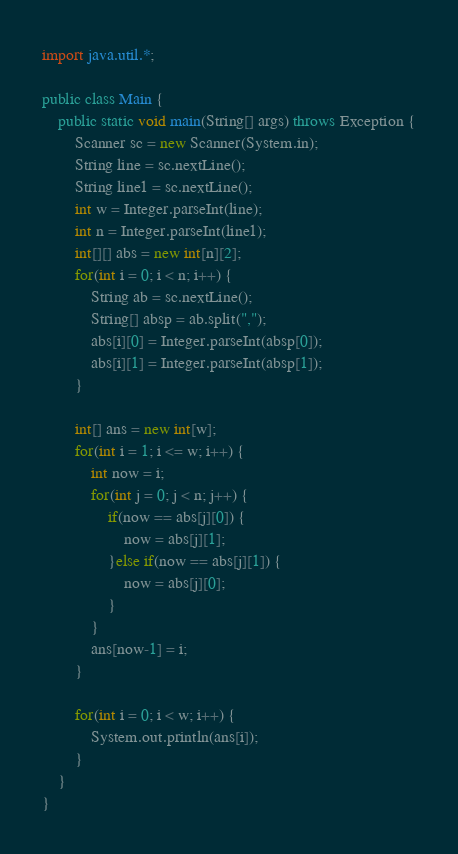Convert code to text. <code><loc_0><loc_0><loc_500><loc_500><_Java_>import java.util.*;

public class Main {
    public static void main(String[] args) throws Exception {
        Scanner sc = new Scanner(System.in);
        String line = sc.nextLine();
        String line1 = sc.nextLine();
        int w = Integer.parseInt(line);
        int n = Integer.parseInt(line1);
        int[][] abs = new int[n][2];
        for(int i = 0; i < n; i++) {
            String ab = sc.nextLine();
            String[] absp = ab.split(",");
            abs[i][0] = Integer.parseInt(absp[0]);
            abs[i][1] = Integer.parseInt(absp[1]);
        }
        
        int[] ans = new int[w];
        for(int i = 1; i <= w; i++) {
            int now = i;
            for(int j = 0; j < n; j++) {
                if(now == abs[j][0]) {
                    now = abs[j][1];
                }else if(now == abs[j][1]) {
                    now = abs[j][0];
                }
            }
            ans[now-1] = i;
        }
        
        for(int i = 0; i < w; i++) {
            System.out.println(ans[i]);
        }
    }
}

</code> 